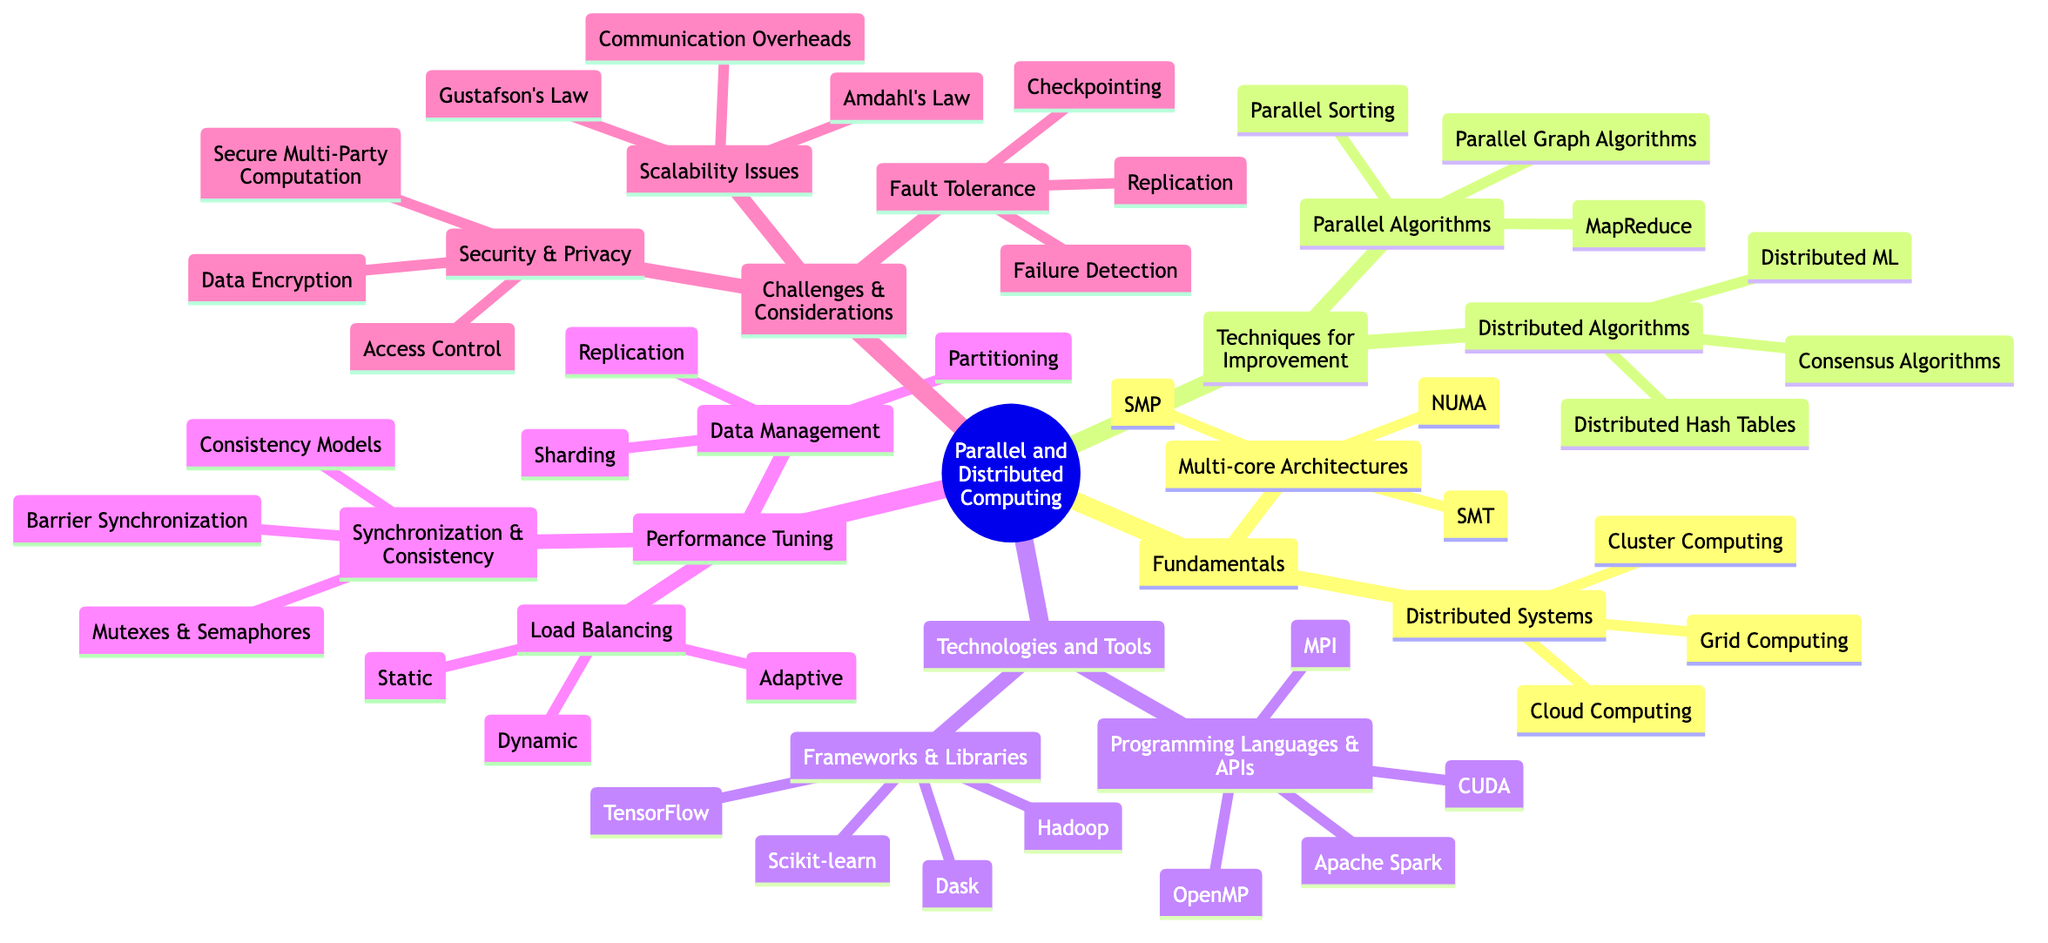What are the three main types of multi-core architectures mentioned? The diagram lists "Symmetric Multiprocessing (SMP)", "Non-Uniform Memory Access (NUMA)", and "Simultaneous Multithreading (SMT)" under the "Multi-core Architectures" node.
Answer: Symmetric Multiprocessing, Non-Uniform Memory Access, Simultaneous Multithreading How many parallel algorithms are listed in the mind map? The "Parallel Algorithms" node includes "MapReduce", "Parallel Sorting", and "Parallel Graph Algorithms". Counting these, there are three items listed.
Answer: 3 What is one of the distributed algorithms mentioned? Under the "Distributed Algorithms" section, examples given include "Consensus Algorithms", "Distributed Hash Tables", and "Distributed Machine Learning". Any of these can serve as an answer.
Answer: Consensus Algorithms Which technique for performance tuning involves dividing workload across multiple resources? The "Load Balancing" node encompasses "Static Load Balancing", "Dynamic Load Balancing", and "Adaptive Load Balancing". The concept of load balancing inherently refers to dividing workloads, making it the main technique for this purpose.
Answer: Load Balancing What is a challenge mentioned related to scalability issues? The "Scalability Issues" section includes "Amdahl's Law", "Gustafson's Law", and "Communication Overheads". These are all recognized as challenges in scalability, and any of them could be a valid answer.
Answer: Amdahl's Law What is one method listed under fault tolerance? The "Fault Tolerance" node contains "Checkpointing", "Replication", and "Failure Detection". Each of these methods helps address fault tolerance in computing systems, and any of these terms would be correct.
Answer: Checkpointing Which programming language or API is associated with CUDA? In the "Programming Languages and APIs" section, "CUDA" is directly mentioned as one of the tools available for parallel and distributed computing, implying it is both a language and an API for computing.
Answer: CUDA How many frameworks or libraries are mentioned for technologies and tools? The "Frameworks and Libraries" section lists "TensorFlow", "Hadoop", "Scikit-learn", and "Dask", resulting in a total of four distinct frameworks or libraries identified in this category.
Answer: 4 What are the four categories mentioned in "Performance Tuning"? The sections under "Performance Tuning" are "Load Balancing", "Data Management", "Synchronization and Consistency". Noting all categories yields three distinct areas.
Answer: Load Balancing, Data Management, Synchronization and Consistency 